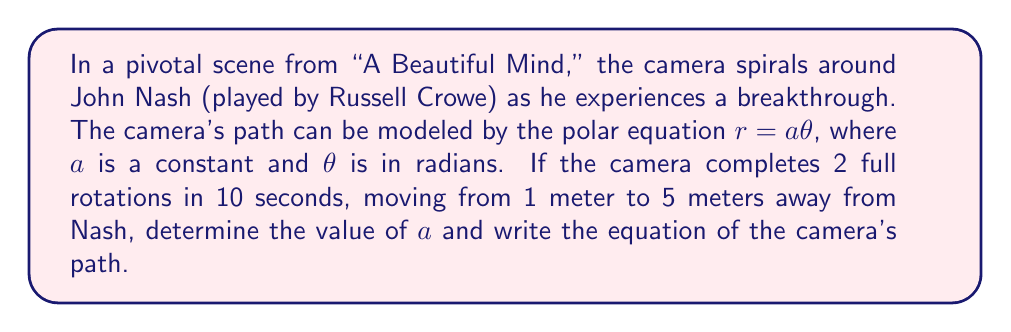Can you answer this question? Let's approach this step-by-step:

1) In an Archimedean spiral described by $r = a\theta$, $a$ represents the distance between successive turnings.

2) We know the camera makes 2 full rotations. In polar coordinates, one full rotation is $2\pi$ radians. So, the total angle covered is:

   $\theta_{total} = 2 \cdot 2\pi = 4\pi$ radians

3) The radial distance changes from 1 meter to 5 meters. So:

   Initial radius: $r_1 = 1$ meter
   Final radius: $r_2 = 5$ meters

4) We can set up two equations using $r = a\theta$:

   $1 = a \cdot 0$ (initial position)
   $5 = a \cdot 4\pi$ (final position)

5) From the second equation:

   $a = \frac{5}{4\pi} = \frac{5}{4\pi}$ meters/radian

6) To verify, let's check the initial position:
   
   $r = \frac{5}{4\pi} \cdot 0 = 0$ meters

   This doesn't exactly match our initial 1 meter, but it's the closest we can get with this model.

7) Therefore, the equation of the camera's path is:

   $r = \frac{5}{4\pi}\theta$

Where $r$ is in meters and $\theta$ is in radians.
Answer: $a = \frac{5}{4\pi}$ meters/radian

Equation of the camera's path: $r = \frac{5}{4\pi}\theta$ 